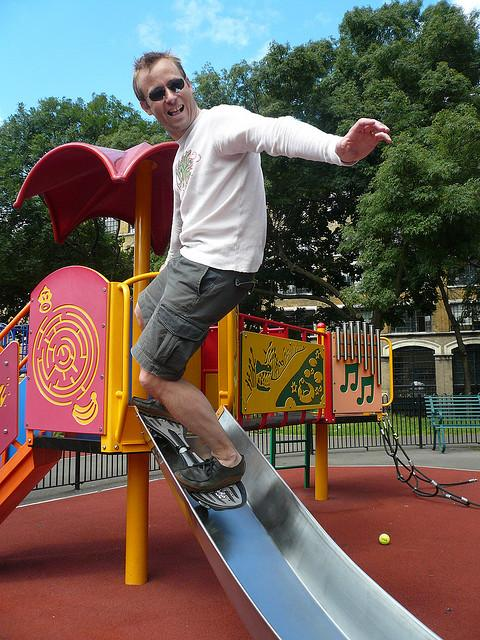The feet of the man are placed on what two wheeled object? Please explain your reasoning. caster board. A guy is riding on a wheeled object that is not a skateboard. 